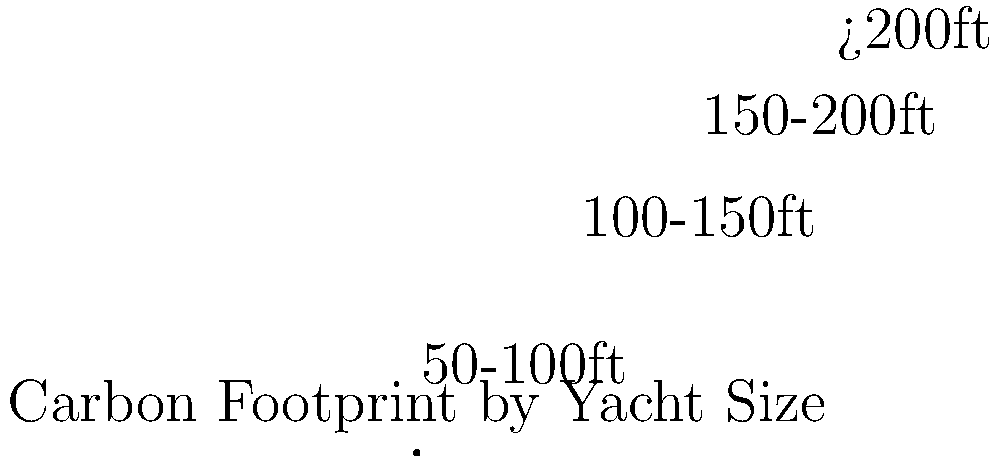As an environmental lawyer challenging luxury yachting practices, you're analyzing the carbon footprint of various yacht sizes. The pie chart shows the distribution of carbon emissions by yacht size. If the total annual carbon footprint for all yachts is 1,000,000 metric tons of CO2, how many metric tons of CO2 are emitted by yachts in the 100-150ft category? To solve this problem, we need to follow these steps:

1. Identify the percentage of carbon footprint attributed to yachts in the 100-150ft category from the pie chart.
2. Calculate the amount of CO2 emissions based on the total annual carbon footprint.

Step 1: From the pie chart, we can see that the 100-150ft category accounts for 25% of the total carbon footprint.

Step 2: Calculate the CO2 emissions for the 100-150ft category:
* Total annual carbon footprint = 1,000,000 metric tons of CO2
* Percentage for 100-150ft category = 25% = 0.25
* CO2 emissions for 100-150ft category = $1,000,000 \times 0.25 = 250,000$ metric tons of CO2

Therefore, yachts in the 100-150ft category emit 250,000 metric tons of CO2 annually.
Answer: 250,000 metric tons 